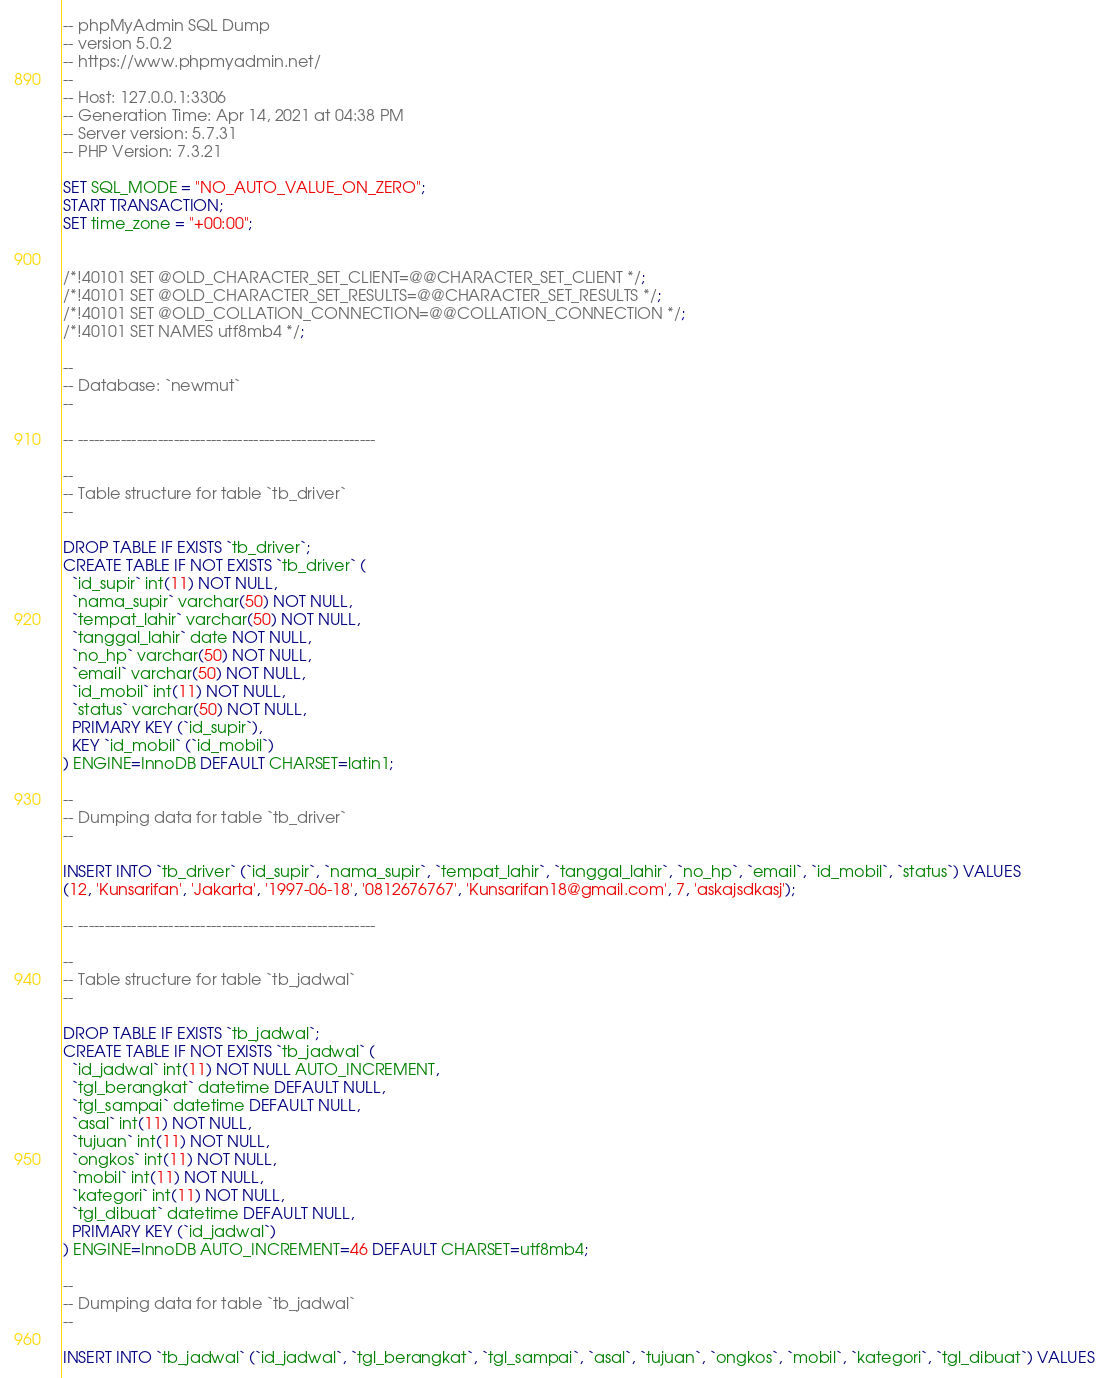<code> <loc_0><loc_0><loc_500><loc_500><_SQL_>-- phpMyAdmin SQL Dump
-- version 5.0.2
-- https://www.phpmyadmin.net/
--
-- Host: 127.0.0.1:3306
-- Generation Time: Apr 14, 2021 at 04:38 PM
-- Server version: 5.7.31
-- PHP Version: 7.3.21

SET SQL_MODE = "NO_AUTO_VALUE_ON_ZERO";
START TRANSACTION;
SET time_zone = "+00:00";


/*!40101 SET @OLD_CHARACTER_SET_CLIENT=@@CHARACTER_SET_CLIENT */;
/*!40101 SET @OLD_CHARACTER_SET_RESULTS=@@CHARACTER_SET_RESULTS */;
/*!40101 SET @OLD_COLLATION_CONNECTION=@@COLLATION_CONNECTION */;
/*!40101 SET NAMES utf8mb4 */;

--
-- Database: `newmut`
--

-- --------------------------------------------------------

--
-- Table structure for table `tb_driver`
--

DROP TABLE IF EXISTS `tb_driver`;
CREATE TABLE IF NOT EXISTS `tb_driver` (
  `id_supir` int(11) NOT NULL,
  `nama_supir` varchar(50) NOT NULL,
  `tempat_lahir` varchar(50) NOT NULL,
  `tanggal_lahir` date NOT NULL,
  `no_hp` varchar(50) NOT NULL,
  `email` varchar(50) NOT NULL,
  `id_mobil` int(11) NOT NULL,
  `status` varchar(50) NOT NULL,
  PRIMARY KEY (`id_supir`),
  KEY `id_mobil` (`id_mobil`)
) ENGINE=InnoDB DEFAULT CHARSET=latin1;

--
-- Dumping data for table `tb_driver`
--

INSERT INTO `tb_driver` (`id_supir`, `nama_supir`, `tempat_lahir`, `tanggal_lahir`, `no_hp`, `email`, `id_mobil`, `status`) VALUES
(12, 'Kunsarifan', 'Jakarta', '1997-06-18', '0812676767', 'Kunsarifan18@gmail.com', 7, 'askajsdkasj');

-- --------------------------------------------------------

--
-- Table structure for table `tb_jadwal`
--

DROP TABLE IF EXISTS `tb_jadwal`;
CREATE TABLE IF NOT EXISTS `tb_jadwal` (
  `id_jadwal` int(11) NOT NULL AUTO_INCREMENT,
  `tgl_berangkat` datetime DEFAULT NULL,
  `tgl_sampai` datetime DEFAULT NULL,
  `asal` int(11) NOT NULL,
  `tujuan` int(11) NOT NULL,
  `ongkos` int(11) NOT NULL,
  `mobil` int(11) NOT NULL,
  `kategori` int(11) NOT NULL,
  `tgl_dibuat` datetime DEFAULT NULL,
  PRIMARY KEY (`id_jadwal`)
) ENGINE=InnoDB AUTO_INCREMENT=46 DEFAULT CHARSET=utf8mb4;

--
-- Dumping data for table `tb_jadwal`
--

INSERT INTO `tb_jadwal` (`id_jadwal`, `tgl_berangkat`, `tgl_sampai`, `asal`, `tujuan`, `ongkos`, `mobil`, `kategori`, `tgl_dibuat`) VALUES</code> 